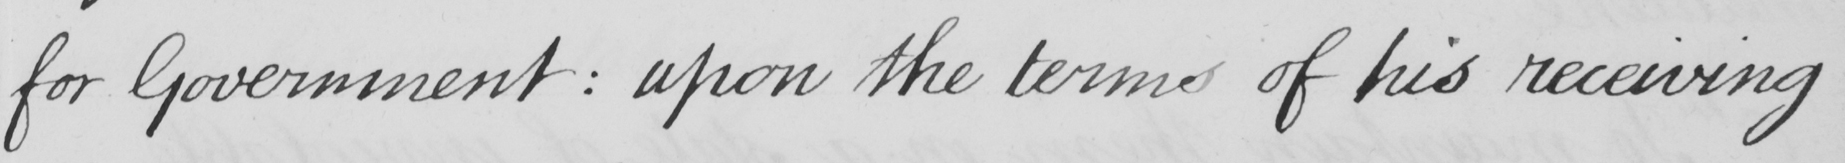Transcribe the text shown in this historical manuscript line. for Government :  upon the terms of his receiving 